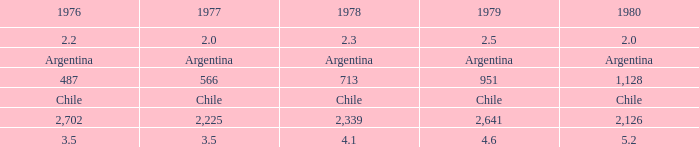What is 1977 when 1978 is 4.1? 3.5. 